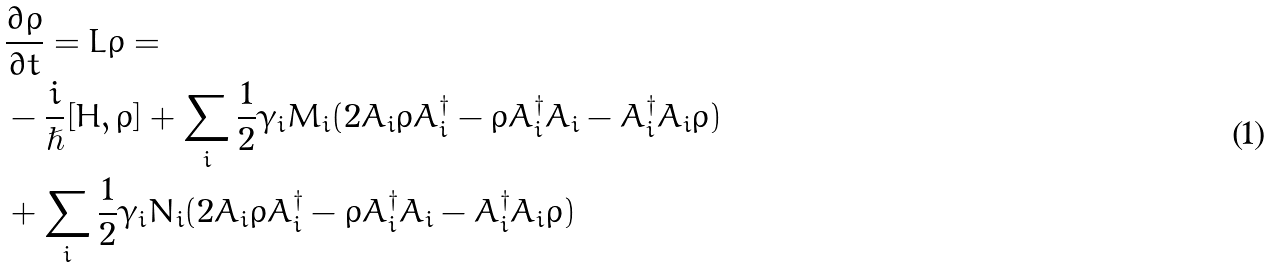Convert formula to latex. <formula><loc_0><loc_0><loc_500><loc_500>& \frac { \partial \rho } { \partial t } = L \rho = \\ & - \frac { i } { \hslash } [ H , \rho ] + \sum _ { i } \frac { 1 } { 2 } \gamma _ { i } M _ { i } ( 2 A _ { i } \rho A _ { i } ^ { \dagger } - \rho A _ { i } ^ { \dagger } A _ { i } - A _ { i } ^ { \dagger } A _ { i } \rho ) \\ & + \sum _ { i } \frac { 1 } { 2 } \gamma _ { i } N _ { i } ( 2 A _ { i } \rho A _ { i } ^ { \dagger } - \rho A _ { i } ^ { \dagger } A _ { i } - A _ { i } ^ { \dagger } A _ { i } \rho )</formula> 